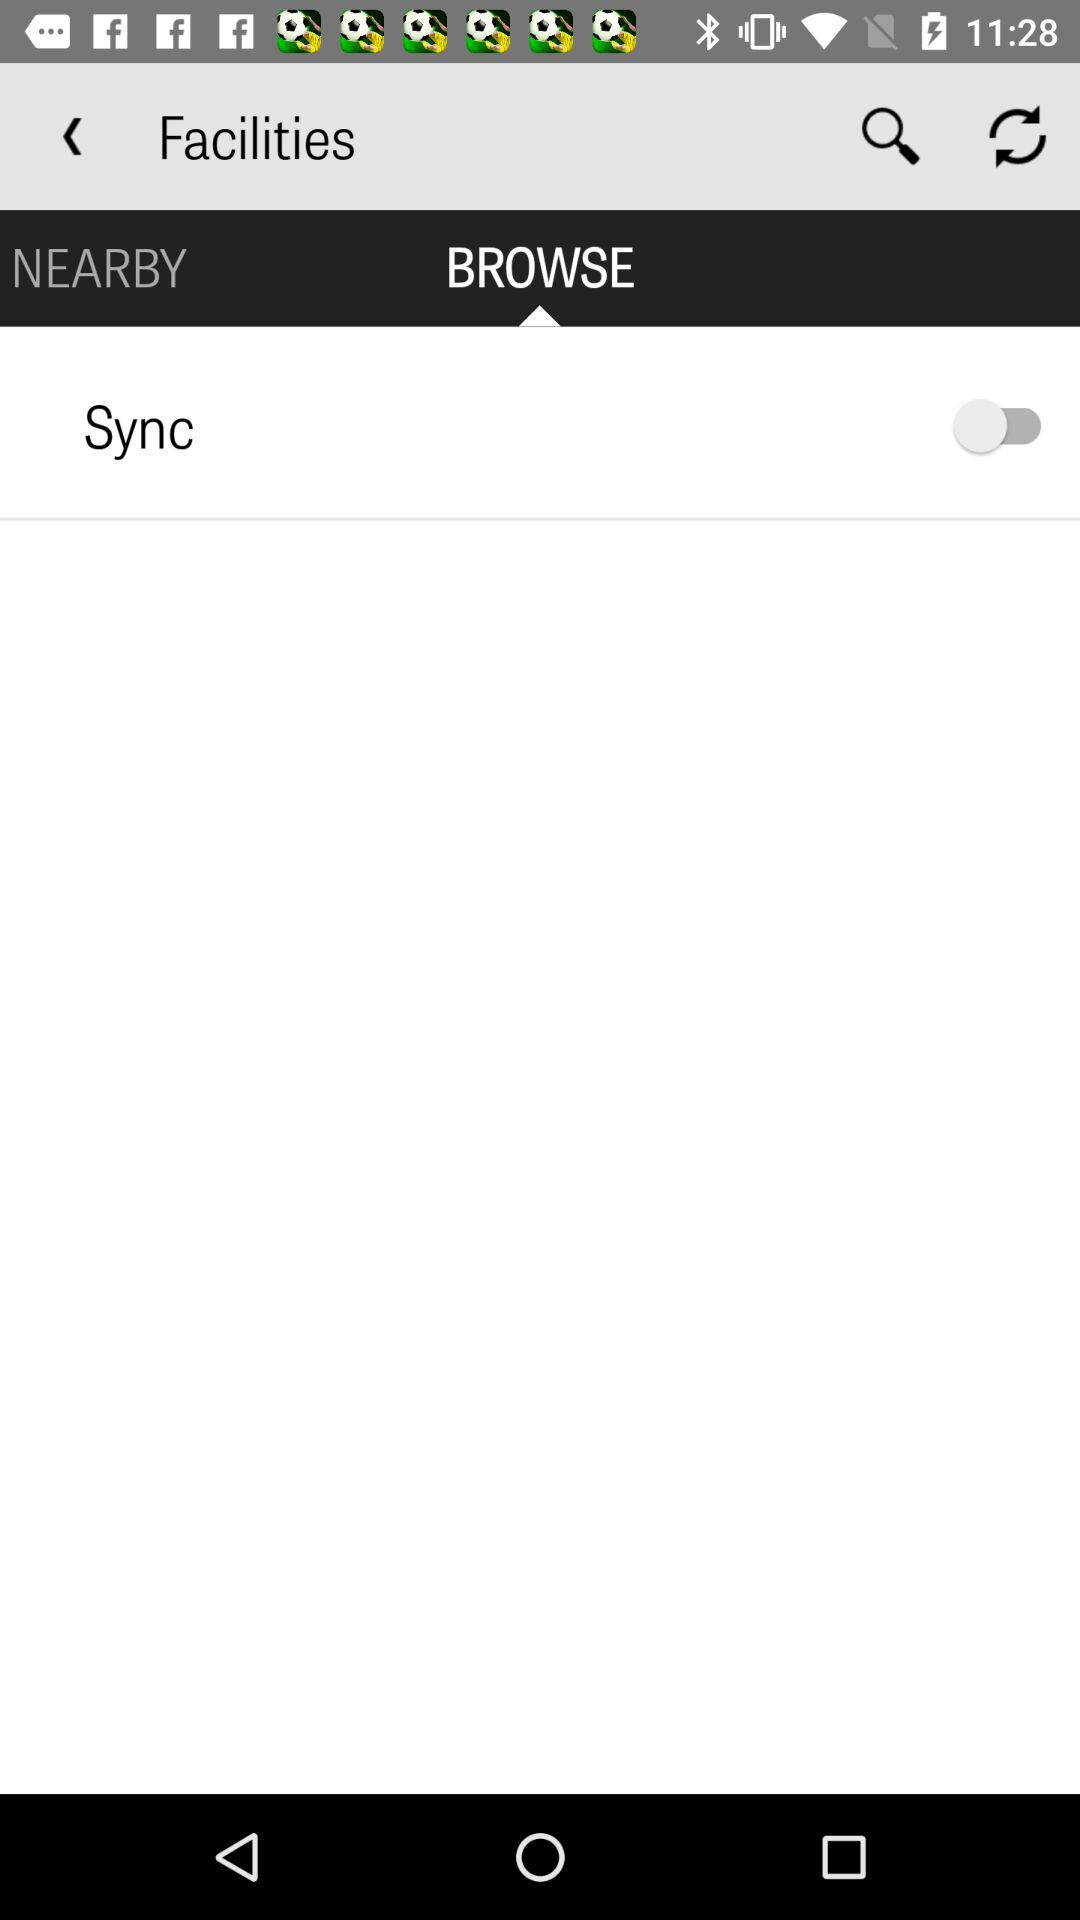What is the selected tab? The selected tab is "BROWSE". 